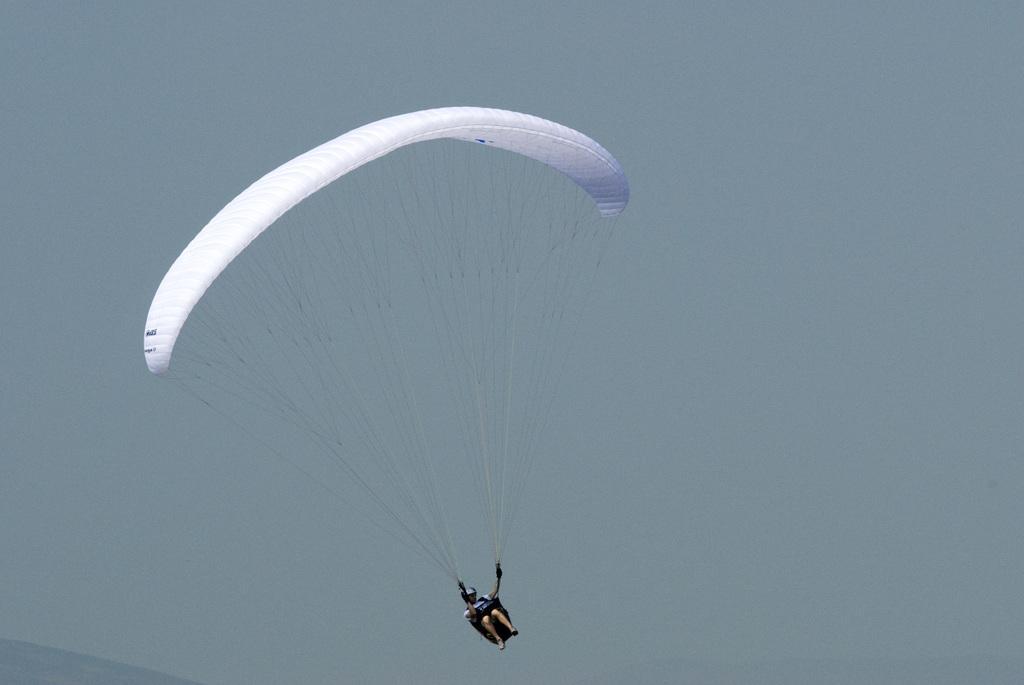Could you give a brief overview of what you see in this image? This picture is clicked outside the city. In the foreground there is a person flying a parachute. In the background we can see the sky. 